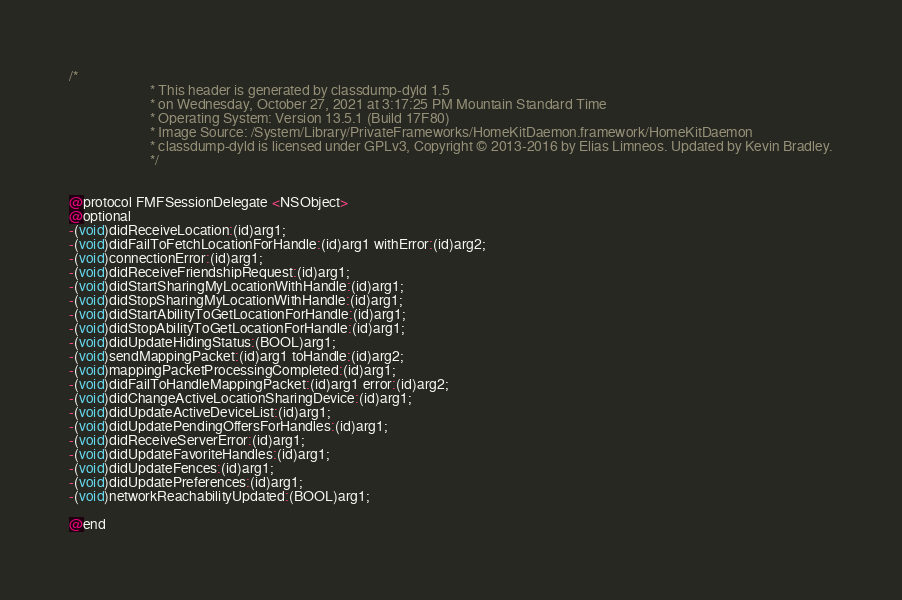<code> <loc_0><loc_0><loc_500><loc_500><_C_>/*
                       * This header is generated by classdump-dyld 1.5
                       * on Wednesday, October 27, 2021 at 3:17:25 PM Mountain Standard Time
                       * Operating System: Version 13.5.1 (Build 17F80)
                       * Image Source: /System/Library/PrivateFrameworks/HomeKitDaemon.framework/HomeKitDaemon
                       * classdump-dyld is licensed under GPLv3, Copyright © 2013-2016 by Elias Limneos. Updated by Kevin Bradley.
                       */


@protocol FMFSessionDelegate <NSObject>
@optional
-(void)didReceiveLocation:(id)arg1;
-(void)didFailToFetchLocationForHandle:(id)arg1 withError:(id)arg2;
-(void)connectionError:(id)arg1;
-(void)didReceiveFriendshipRequest:(id)arg1;
-(void)didStartSharingMyLocationWithHandle:(id)arg1;
-(void)didStopSharingMyLocationWithHandle:(id)arg1;
-(void)didStartAbilityToGetLocationForHandle:(id)arg1;
-(void)didStopAbilityToGetLocationForHandle:(id)arg1;
-(void)didUpdateHidingStatus:(BOOL)arg1;
-(void)sendMappingPacket:(id)arg1 toHandle:(id)arg2;
-(void)mappingPacketProcessingCompleted:(id)arg1;
-(void)didFailToHandleMappingPacket:(id)arg1 error:(id)arg2;
-(void)didChangeActiveLocationSharingDevice:(id)arg1;
-(void)didUpdateActiveDeviceList:(id)arg1;
-(void)didUpdatePendingOffersForHandles:(id)arg1;
-(void)didReceiveServerError:(id)arg1;
-(void)didUpdateFavoriteHandles:(id)arg1;
-(void)didUpdateFences:(id)arg1;
-(void)didUpdatePreferences:(id)arg1;
-(void)networkReachabilityUpdated:(BOOL)arg1;

@end

</code> 